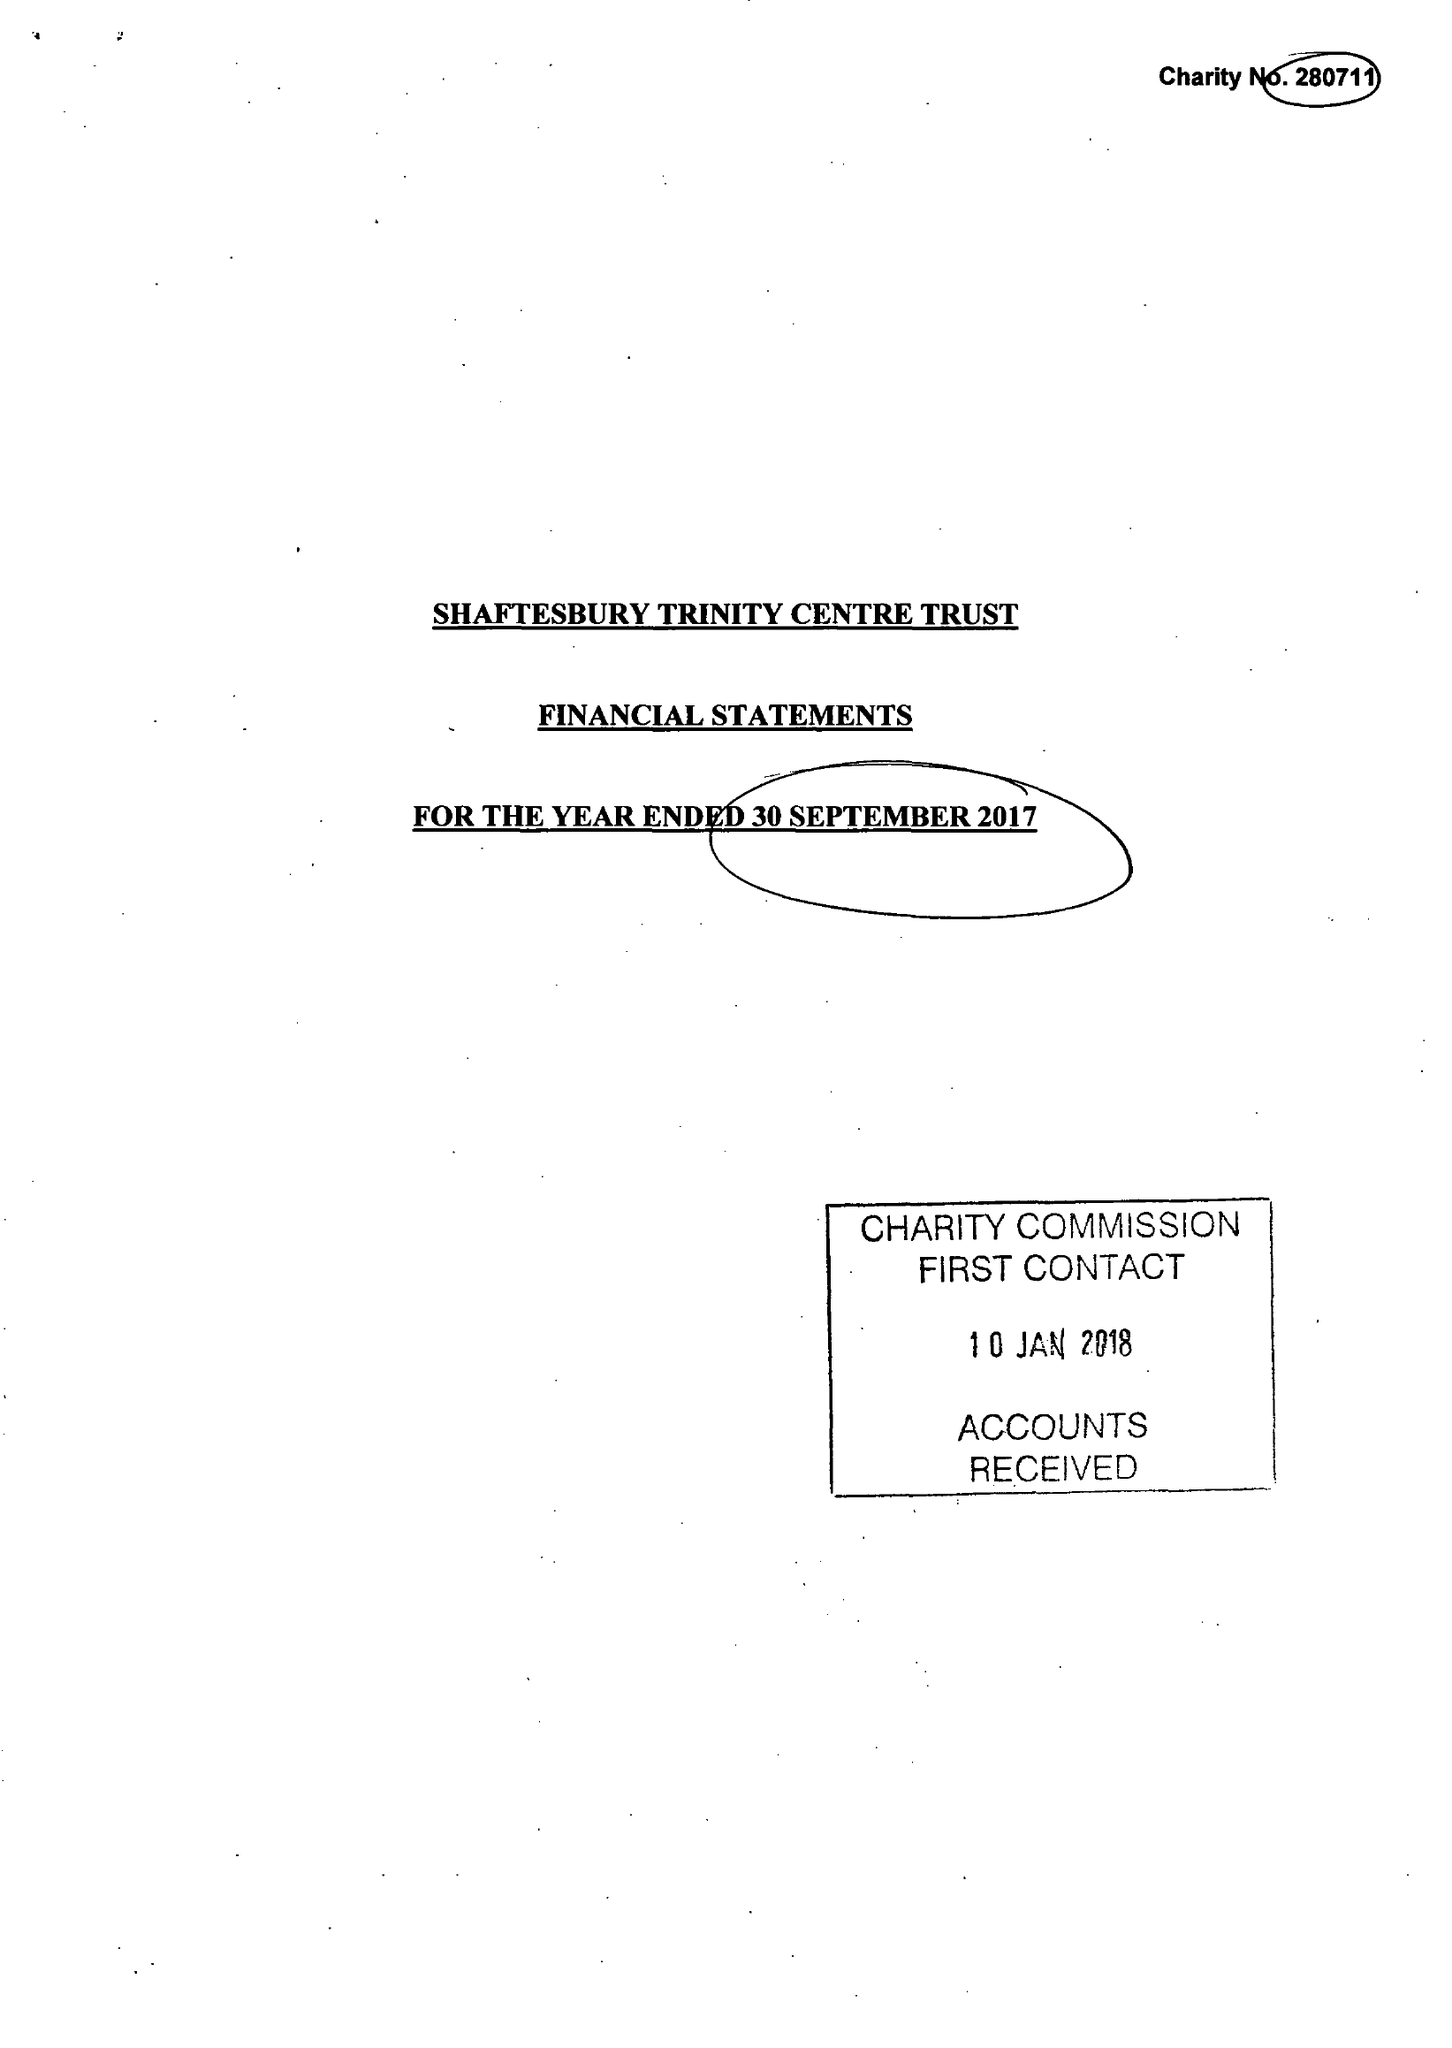What is the value for the address__post_town?
Answer the question using a single word or phrase. GILLINGHAM 